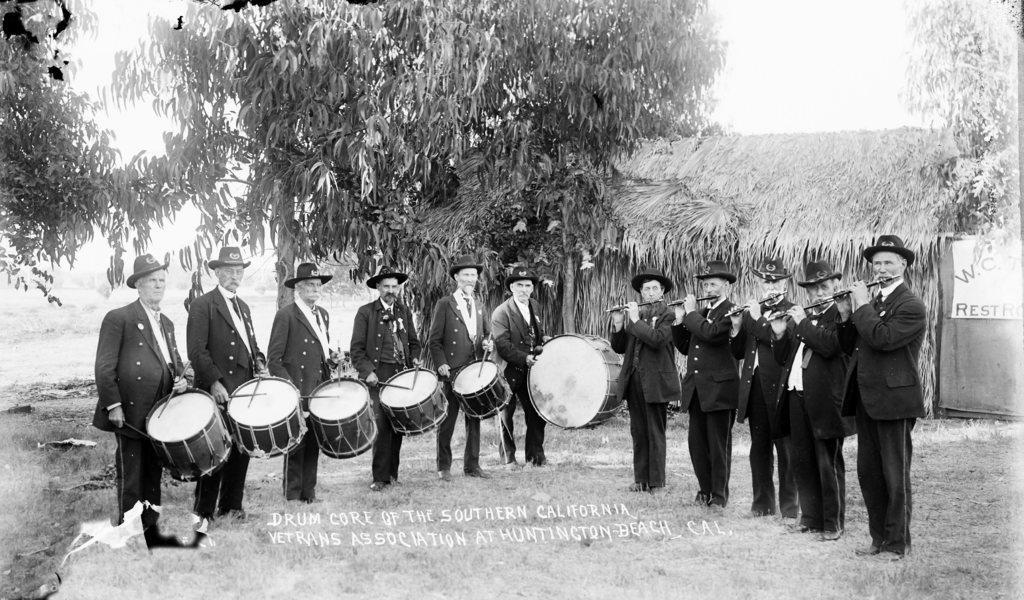Describe this image in one or two sentences. In this picture there are many men standing holding drums in their hands and some of them are playing flute. All of them are wearing hats on their heads. In the background there is a hut and trees here. We can observe a sky too. 